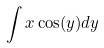<formula> <loc_0><loc_0><loc_500><loc_500>\int x \cos ( y ) d y</formula> 